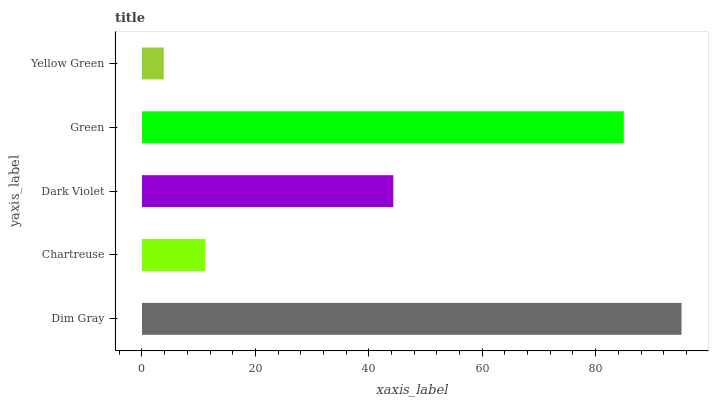Is Yellow Green the minimum?
Answer yes or no. Yes. Is Dim Gray the maximum?
Answer yes or no. Yes. Is Chartreuse the minimum?
Answer yes or no. No. Is Chartreuse the maximum?
Answer yes or no. No. Is Dim Gray greater than Chartreuse?
Answer yes or no. Yes. Is Chartreuse less than Dim Gray?
Answer yes or no. Yes. Is Chartreuse greater than Dim Gray?
Answer yes or no. No. Is Dim Gray less than Chartreuse?
Answer yes or no. No. Is Dark Violet the high median?
Answer yes or no. Yes. Is Dark Violet the low median?
Answer yes or no. Yes. Is Yellow Green the high median?
Answer yes or no. No. Is Yellow Green the low median?
Answer yes or no. No. 